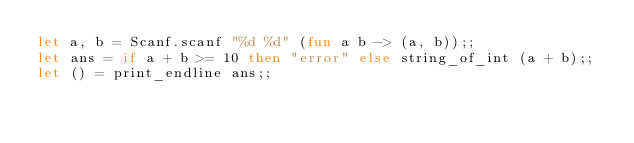Convert code to text. <code><loc_0><loc_0><loc_500><loc_500><_OCaml_>let a, b = Scanf.scanf "%d %d" (fun a b -> (a, b));;
let ans = if a + b >= 10 then "error" else string_of_int (a + b);;
let () = print_endline ans;;
</code> 